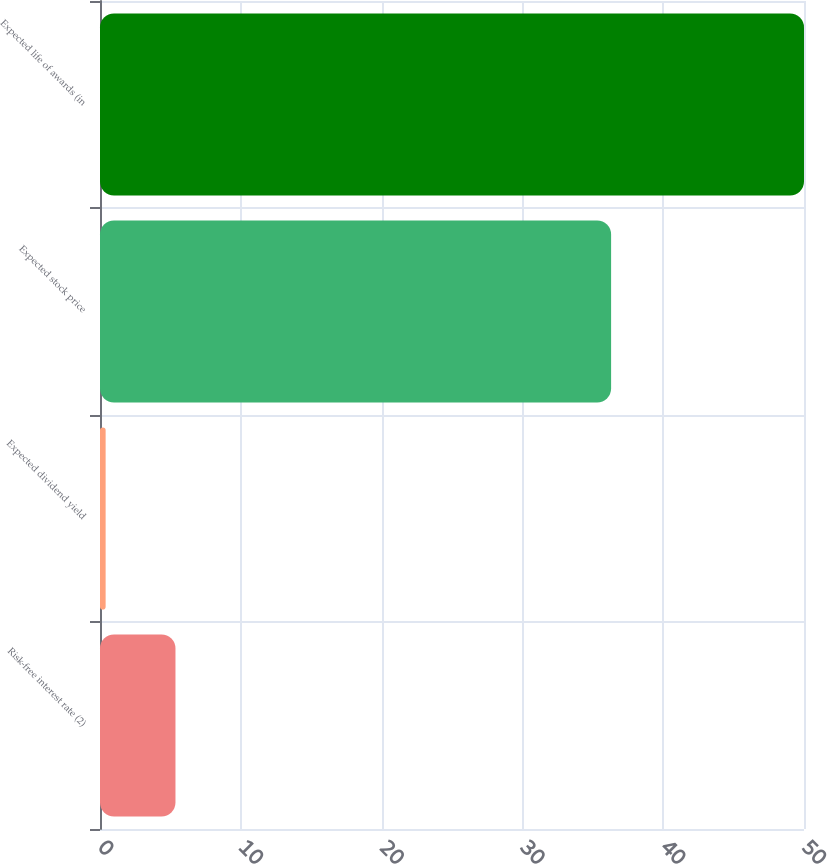<chart> <loc_0><loc_0><loc_500><loc_500><bar_chart><fcel>Risk-free interest rate (2)<fcel>Expected dividend yield<fcel>Expected stock price<fcel>Expected life of awards (in<nl><fcel>5.36<fcel>0.4<fcel>36.3<fcel>50<nl></chart> 